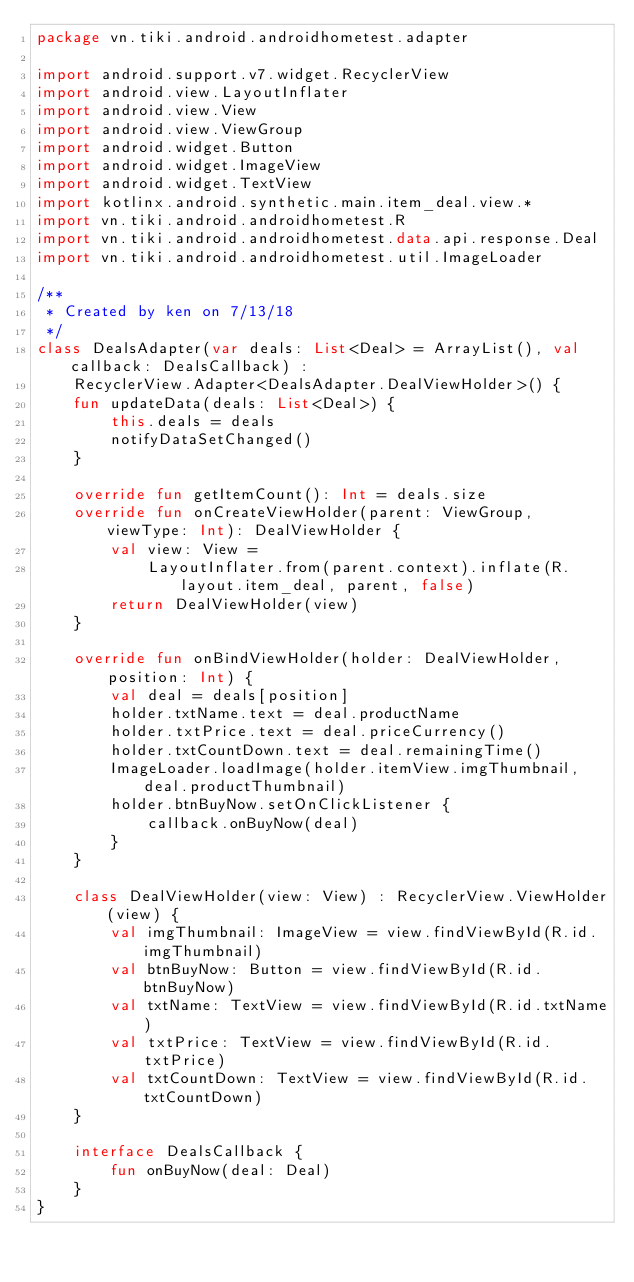<code> <loc_0><loc_0><loc_500><loc_500><_Kotlin_>package vn.tiki.android.androidhometest.adapter

import android.support.v7.widget.RecyclerView
import android.view.LayoutInflater
import android.view.View
import android.view.ViewGroup
import android.widget.Button
import android.widget.ImageView
import android.widget.TextView
import kotlinx.android.synthetic.main.item_deal.view.*
import vn.tiki.android.androidhometest.R
import vn.tiki.android.androidhometest.data.api.response.Deal
import vn.tiki.android.androidhometest.util.ImageLoader

/**
 * Created by ken on 7/13/18
 */
class DealsAdapter(var deals: List<Deal> = ArrayList(), val callback: DealsCallback) :
    RecyclerView.Adapter<DealsAdapter.DealViewHolder>() {
    fun updateData(deals: List<Deal>) {
        this.deals = deals
        notifyDataSetChanged()
    }

    override fun getItemCount(): Int = deals.size
    override fun onCreateViewHolder(parent: ViewGroup, viewType: Int): DealViewHolder {
        val view: View =
            LayoutInflater.from(parent.context).inflate(R.layout.item_deal, parent, false)
        return DealViewHolder(view)
    }

    override fun onBindViewHolder(holder: DealViewHolder, position: Int) {
        val deal = deals[position]
        holder.txtName.text = deal.productName
        holder.txtPrice.text = deal.priceCurrency()
        holder.txtCountDown.text = deal.remainingTime()
        ImageLoader.loadImage(holder.itemView.imgThumbnail, deal.productThumbnail)
        holder.btnBuyNow.setOnClickListener {
            callback.onBuyNow(deal)
        }
    }

    class DealViewHolder(view: View) : RecyclerView.ViewHolder(view) {
        val imgThumbnail: ImageView = view.findViewById(R.id.imgThumbnail)
        val btnBuyNow: Button = view.findViewById(R.id.btnBuyNow)
        val txtName: TextView = view.findViewById(R.id.txtName)
        val txtPrice: TextView = view.findViewById(R.id.txtPrice)
        val txtCountDown: TextView = view.findViewById(R.id.txtCountDown)
    }

    interface DealsCallback {
        fun onBuyNow(deal: Deal)
    }
}</code> 